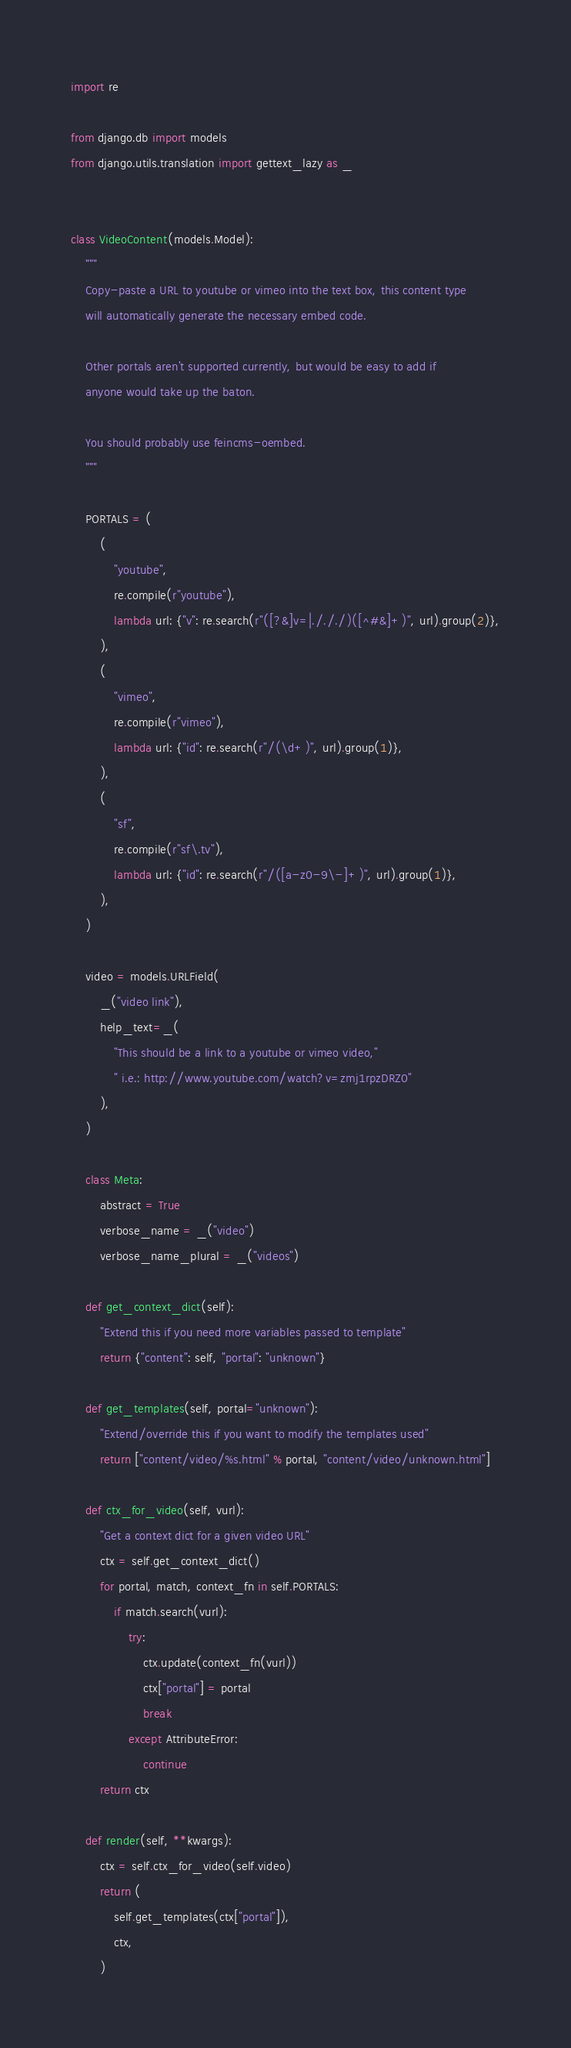Convert code to text. <code><loc_0><loc_0><loc_500><loc_500><_Python_>import re

from django.db import models
from django.utils.translation import gettext_lazy as _


class VideoContent(models.Model):
    """
    Copy-paste a URL to youtube or vimeo into the text box, this content type
    will automatically generate the necessary embed code.

    Other portals aren't supported currently, but would be easy to add if
    anyone would take up the baton.

    You should probably use feincms-oembed.
    """

    PORTALS = (
        (
            "youtube",
            re.compile(r"youtube"),
            lambda url: {"v": re.search(r"([?&]v=|./././)([^#&]+)", url).group(2)},
        ),
        (
            "vimeo",
            re.compile(r"vimeo"),
            lambda url: {"id": re.search(r"/(\d+)", url).group(1)},
        ),
        (
            "sf",
            re.compile(r"sf\.tv"),
            lambda url: {"id": re.search(r"/([a-z0-9\-]+)", url).group(1)},
        ),
    )

    video = models.URLField(
        _("video link"),
        help_text=_(
            "This should be a link to a youtube or vimeo video,"
            " i.e.: http://www.youtube.com/watch?v=zmj1rpzDRZ0"
        ),
    )

    class Meta:
        abstract = True
        verbose_name = _("video")
        verbose_name_plural = _("videos")

    def get_context_dict(self):
        "Extend this if you need more variables passed to template"
        return {"content": self, "portal": "unknown"}

    def get_templates(self, portal="unknown"):
        "Extend/override this if you want to modify the templates used"
        return ["content/video/%s.html" % portal, "content/video/unknown.html"]

    def ctx_for_video(self, vurl):
        "Get a context dict for a given video URL"
        ctx = self.get_context_dict()
        for portal, match, context_fn in self.PORTALS:
            if match.search(vurl):
                try:
                    ctx.update(context_fn(vurl))
                    ctx["portal"] = portal
                    break
                except AttributeError:
                    continue
        return ctx

    def render(self, **kwargs):
        ctx = self.ctx_for_video(self.video)
        return (
            self.get_templates(ctx["portal"]),
            ctx,
        )
</code> 